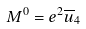Convert formula to latex. <formula><loc_0><loc_0><loc_500><loc_500>M ^ { 0 } = e ^ { 2 } \overline { u } _ { 4 }</formula> 